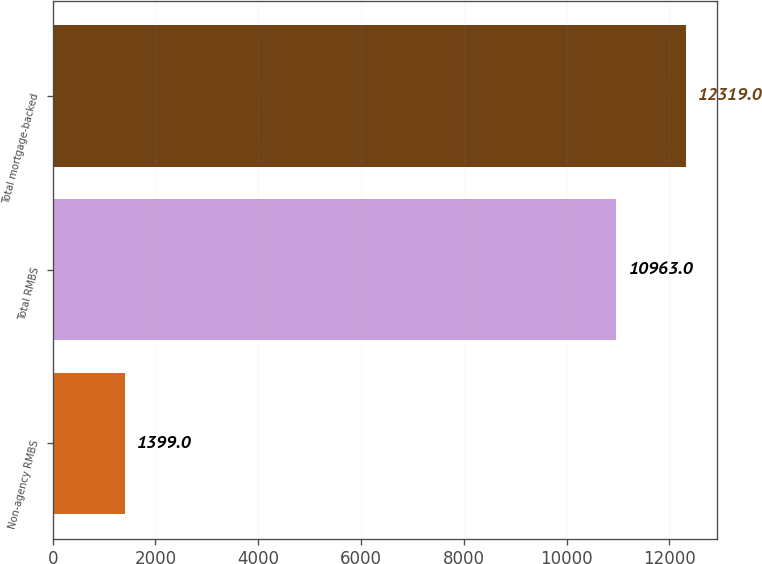Convert chart. <chart><loc_0><loc_0><loc_500><loc_500><bar_chart><fcel>Non-agency RMBS<fcel>Total RMBS<fcel>Total mortgage-backed<nl><fcel>1399<fcel>10963<fcel>12319<nl></chart> 